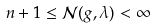Convert formula to latex. <formula><loc_0><loc_0><loc_500><loc_500>n + 1 \leq \mathcal { N } ( g , \lambda ) < \infty</formula> 